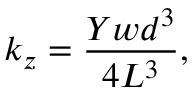Convert formula to latex. <formula><loc_0><loc_0><loc_500><loc_500>k _ { z } = \frac { Y w d ^ { 3 } } { 4 L ^ { 3 } } ,</formula> 